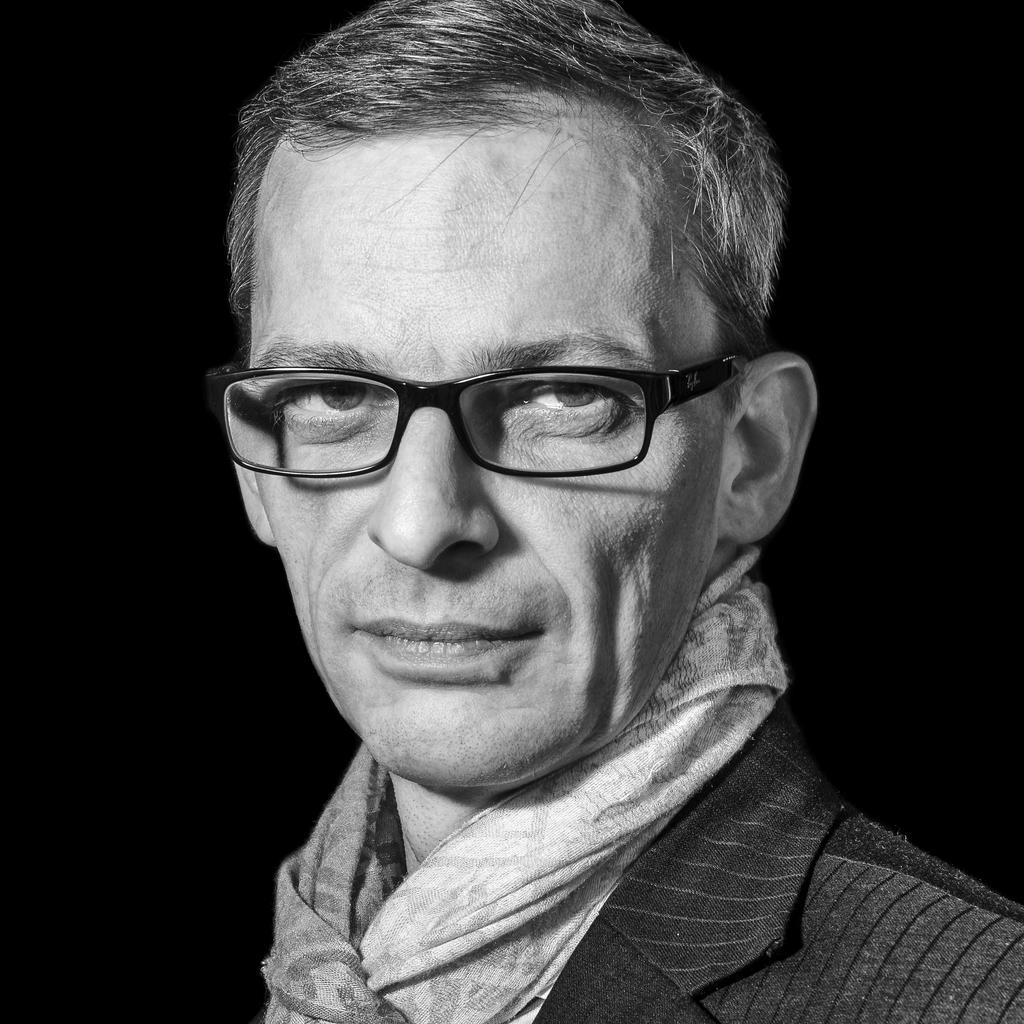Who or what is the main subject of the image? There is a person in the image. What is the person wearing? The person is wearing a black dress and black-colored spectacles. What color dominates the background of the image? The background of the image is black. What type of farm animals can be seen in the image? There are no farm animals present in the image; it features a person wearing a black dress and black-colored spectacles against a black background. Is there a coat visible on the person in the image? There is no coat visible on the person in the image; they are wearing a black dress and black-colored spectacles. 